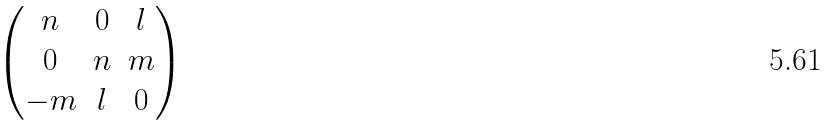Convert formula to latex. <formula><loc_0><loc_0><loc_500><loc_500>\begin{pmatrix} n & 0 & l \\ 0 & n & m \\ - m & l & 0 \end{pmatrix}</formula> 